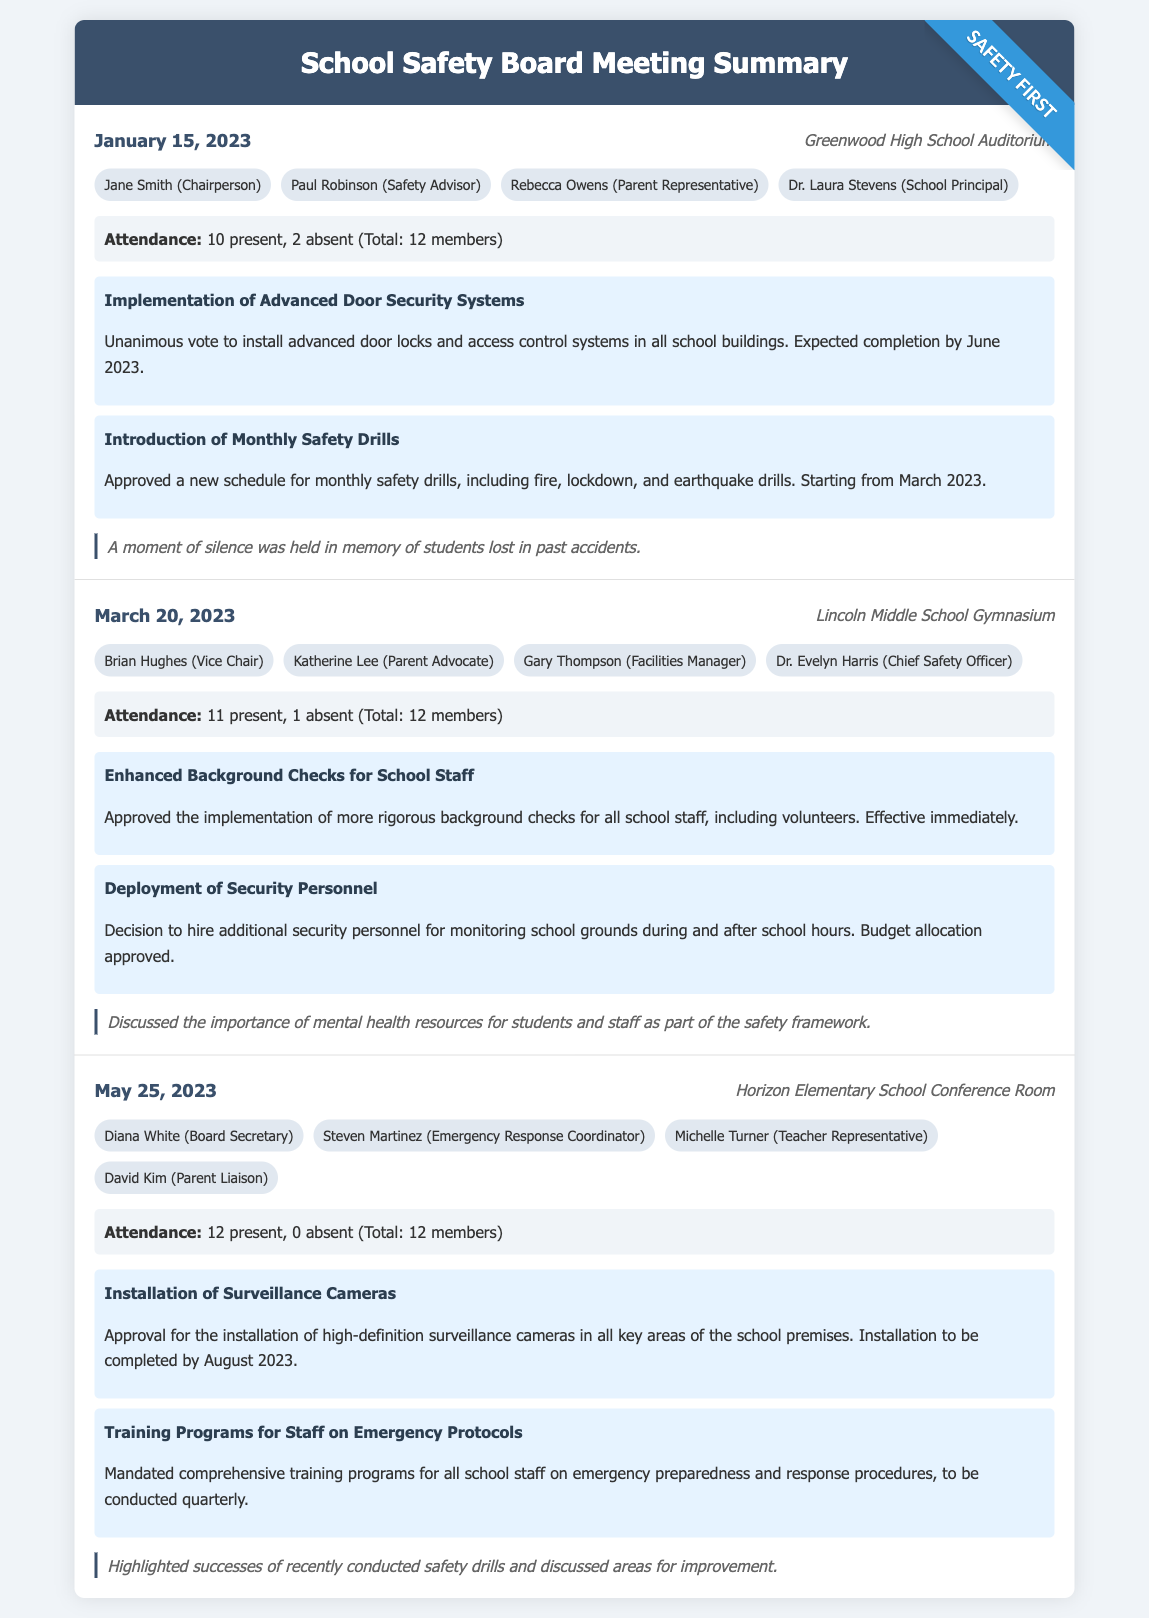what date was the first meeting held? The date of the first meeting is stated at the beginning of the summary for the first meeting section.
Answer: January 15, 2023 how many members were present at the March 20, 2023 meeting? The attendance for the March 20, 2023 meeting indicates the number of members present at that meeting.
Answer: 11 present what was one key decision made in the January 15, 2023 meeting? The document lists specific decisions made during the meetings, and one of the decisions made in the January meeting is about door security systems.
Answer: Implementation of Advanced Door Security Systems who represented parents in the first meeting? The participants of the first meeting includes a listed parent representative.
Answer: Rebecca Owens how many meetings took place before May 25, 2023? The document outlines three meetings with their respective dates before May 25, 2023, which can be counted from the sections.
Answer: 3 meetings what main topic was discussed in the March 20, 2023 meeting? The notes at the end of the March 20, 2023 meeting highlight the subject of mental health resources.
Answer: Mental health resources which school location hosted the May 25, 2023 meeting? The location of the May 25, 2023 meeting is specified in that meeting's header.
Answer: Horizon Elementary School Conference Room how many participants were at the May 25, 2023 meeting? The participants for the May 25, 2023 meeting are clearly listed in that section.
Answer: 4 participants what was the attendance status in the May 25, 2023 meeting? The attendance section of the May 25, 2023 meeting provides information about present and absent members.
Answer: 12 present, 0 absent 